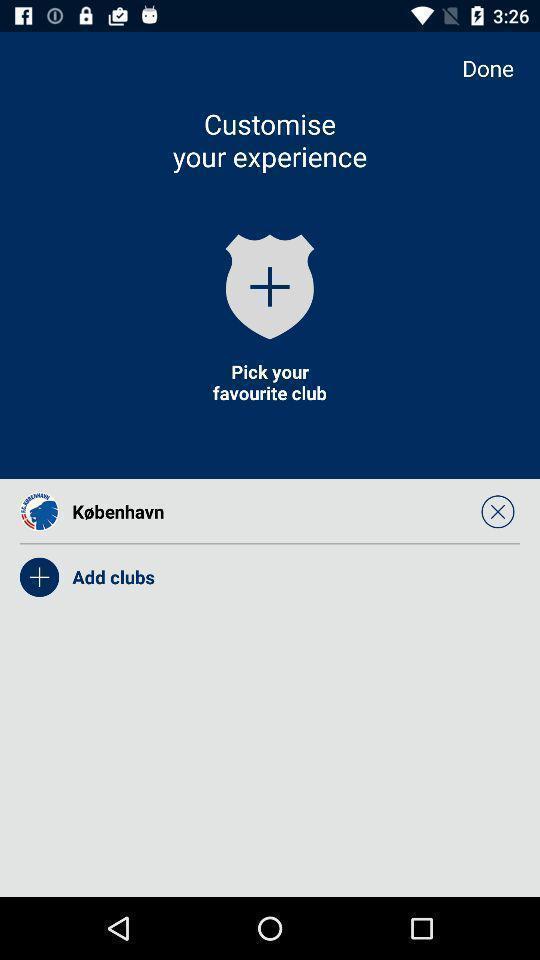Explain the elements present in this screenshot. Screen page asking to pick our favourite club. 